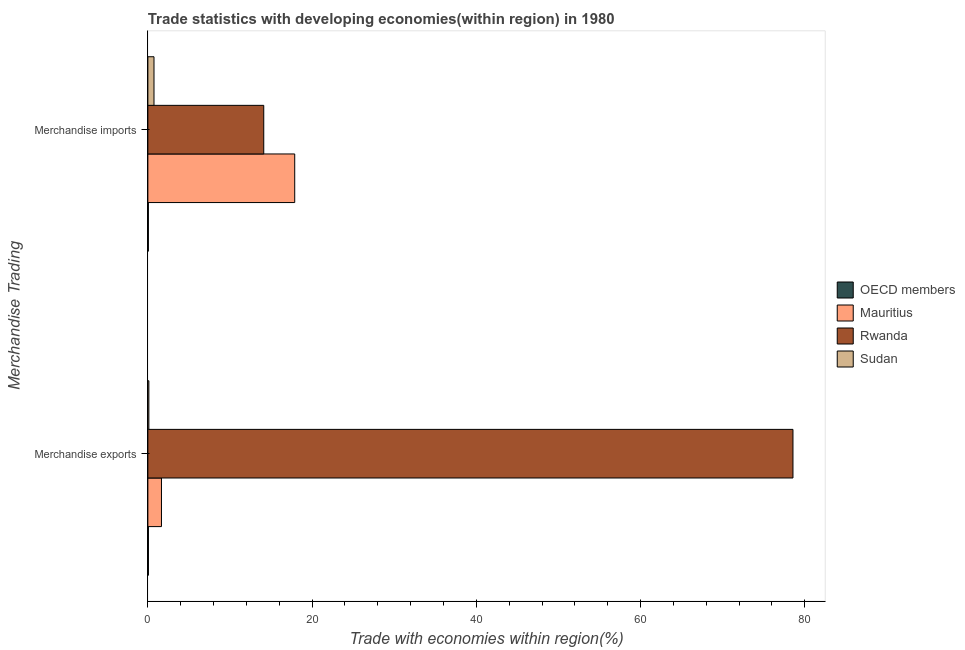How many different coloured bars are there?
Keep it short and to the point. 4. How many bars are there on the 1st tick from the bottom?
Offer a very short reply. 4. What is the label of the 2nd group of bars from the top?
Your answer should be compact. Merchandise exports. What is the merchandise exports in OECD members?
Your answer should be compact. 0.07. Across all countries, what is the maximum merchandise exports?
Keep it short and to the point. 78.56. Across all countries, what is the minimum merchandise imports?
Offer a very short reply. 0.06. In which country was the merchandise exports maximum?
Offer a very short reply. Rwanda. In which country was the merchandise imports minimum?
Your response must be concise. OECD members. What is the total merchandise imports in the graph?
Make the answer very short. 32.8. What is the difference between the merchandise exports in OECD members and that in Mauritius?
Your response must be concise. -1.59. What is the difference between the merchandise exports in Sudan and the merchandise imports in OECD members?
Provide a short and direct response. 0.06. What is the average merchandise exports per country?
Provide a short and direct response. 20.1. What is the difference between the merchandise imports and merchandise exports in Mauritius?
Your answer should be compact. 16.23. What is the ratio of the merchandise exports in Mauritius to that in Rwanda?
Offer a very short reply. 0.02. Are all the bars in the graph horizontal?
Make the answer very short. Yes. What is the difference between two consecutive major ticks on the X-axis?
Provide a short and direct response. 20. Are the values on the major ticks of X-axis written in scientific E-notation?
Ensure brevity in your answer.  No. Does the graph contain any zero values?
Offer a very short reply. No. Where does the legend appear in the graph?
Your answer should be very brief. Center right. How many legend labels are there?
Offer a very short reply. 4. How are the legend labels stacked?
Offer a very short reply. Vertical. What is the title of the graph?
Keep it short and to the point. Trade statistics with developing economies(within region) in 1980. What is the label or title of the X-axis?
Offer a terse response. Trade with economies within region(%). What is the label or title of the Y-axis?
Make the answer very short. Merchandise Trading. What is the Trade with economies within region(%) in OECD members in Merchandise exports?
Offer a very short reply. 0.07. What is the Trade with economies within region(%) in Mauritius in Merchandise exports?
Keep it short and to the point. 1.66. What is the Trade with economies within region(%) of Rwanda in Merchandise exports?
Give a very brief answer. 78.56. What is the Trade with economies within region(%) in Sudan in Merchandise exports?
Your response must be concise. 0.12. What is the Trade with economies within region(%) of OECD members in Merchandise imports?
Provide a short and direct response. 0.06. What is the Trade with economies within region(%) of Mauritius in Merchandise imports?
Your response must be concise. 17.88. What is the Trade with economies within region(%) in Rwanda in Merchandise imports?
Make the answer very short. 14.11. What is the Trade with economies within region(%) of Sudan in Merchandise imports?
Your response must be concise. 0.75. Across all Merchandise Trading, what is the maximum Trade with economies within region(%) of OECD members?
Your response must be concise. 0.07. Across all Merchandise Trading, what is the maximum Trade with economies within region(%) in Mauritius?
Provide a short and direct response. 17.88. Across all Merchandise Trading, what is the maximum Trade with economies within region(%) in Rwanda?
Provide a succinct answer. 78.56. Across all Merchandise Trading, what is the maximum Trade with economies within region(%) of Sudan?
Keep it short and to the point. 0.75. Across all Merchandise Trading, what is the minimum Trade with economies within region(%) in OECD members?
Keep it short and to the point. 0.06. Across all Merchandise Trading, what is the minimum Trade with economies within region(%) in Mauritius?
Your response must be concise. 1.66. Across all Merchandise Trading, what is the minimum Trade with economies within region(%) of Rwanda?
Offer a terse response. 14.11. Across all Merchandise Trading, what is the minimum Trade with economies within region(%) of Sudan?
Provide a succinct answer. 0.12. What is the total Trade with economies within region(%) of OECD members in the graph?
Offer a very short reply. 0.13. What is the total Trade with economies within region(%) in Mauritius in the graph?
Provide a succinct answer. 19.54. What is the total Trade with economies within region(%) in Rwanda in the graph?
Provide a succinct answer. 92.67. What is the total Trade with economies within region(%) in Sudan in the graph?
Your answer should be compact. 0.87. What is the difference between the Trade with economies within region(%) of OECD members in Merchandise exports and that in Merchandise imports?
Give a very brief answer. 0.01. What is the difference between the Trade with economies within region(%) in Mauritius in Merchandise exports and that in Merchandise imports?
Provide a short and direct response. -16.23. What is the difference between the Trade with economies within region(%) of Rwanda in Merchandise exports and that in Merchandise imports?
Your response must be concise. 64.45. What is the difference between the Trade with economies within region(%) of Sudan in Merchandise exports and that in Merchandise imports?
Offer a terse response. -0.62. What is the difference between the Trade with economies within region(%) of OECD members in Merchandise exports and the Trade with economies within region(%) of Mauritius in Merchandise imports?
Give a very brief answer. -17.82. What is the difference between the Trade with economies within region(%) in OECD members in Merchandise exports and the Trade with economies within region(%) in Rwanda in Merchandise imports?
Give a very brief answer. -14.04. What is the difference between the Trade with economies within region(%) in OECD members in Merchandise exports and the Trade with economies within region(%) in Sudan in Merchandise imports?
Offer a terse response. -0.68. What is the difference between the Trade with economies within region(%) in Mauritius in Merchandise exports and the Trade with economies within region(%) in Rwanda in Merchandise imports?
Offer a very short reply. -12.46. What is the difference between the Trade with economies within region(%) of Mauritius in Merchandise exports and the Trade with economies within region(%) of Sudan in Merchandise imports?
Provide a succinct answer. 0.91. What is the difference between the Trade with economies within region(%) in Rwanda in Merchandise exports and the Trade with economies within region(%) in Sudan in Merchandise imports?
Your answer should be compact. 77.81. What is the average Trade with economies within region(%) in OECD members per Merchandise Trading?
Provide a short and direct response. 0.06. What is the average Trade with economies within region(%) of Mauritius per Merchandise Trading?
Make the answer very short. 9.77. What is the average Trade with economies within region(%) of Rwanda per Merchandise Trading?
Ensure brevity in your answer.  46.33. What is the average Trade with economies within region(%) in Sudan per Merchandise Trading?
Ensure brevity in your answer.  0.43. What is the difference between the Trade with economies within region(%) of OECD members and Trade with economies within region(%) of Mauritius in Merchandise exports?
Provide a succinct answer. -1.59. What is the difference between the Trade with economies within region(%) of OECD members and Trade with economies within region(%) of Rwanda in Merchandise exports?
Offer a very short reply. -78.49. What is the difference between the Trade with economies within region(%) of OECD members and Trade with economies within region(%) of Sudan in Merchandise exports?
Give a very brief answer. -0.05. What is the difference between the Trade with economies within region(%) of Mauritius and Trade with economies within region(%) of Rwanda in Merchandise exports?
Your answer should be very brief. -76.9. What is the difference between the Trade with economies within region(%) of Mauritius and Trade with economies within region(%) of Sudan in Merchandise exports?
Make the answer very short. 1.53. What is the difference between the Trade with economies within region(%) in Rwanda and Trade with economies within region(%) in Sudan in Merchandise exports?
Keep it short and to the point. 78.44. What is the difference between the Trade with economies within region(%) of OECD members and Trade with economies within region(%) of Mauritius in Merchandise imports?
Provide a short and direct response. -17.82. What is the difference between the Trade with economies within region(%) of OECD members and Trade with economies within region(%) of Rwanda in Merchandise imports?
Provide a succinct answer. -14.05. What is the difference between the Trade with economies within region(%) in OECD members and Trade with economies within region(%) in Sudan in Merchandise imports?
Your response must be concise. -0.69. What is the difference between the Trade with economies within region(%) of Mauritius and Trade with economies within region(%) of Rwanda in Merchandise imports?
Provide a short and direct response. 3.77. What is the difference between the Trade with economies within region(%) of Mauritius and Trade with economies within region(%) of Sudan in Merchandise imports?
Make the answer very short. 17.14. What is the difference between the Trade with economies within region(%) in Rwanda and Trade with economies within region(%) in Sudan in Merchandise imports?
Offer a very short reply. 13.37. What is the ratio of the Trade with economies within region(%) of OECD members in Merchandise exports to that in Merchandise imports?
Your answer should be very brief. 1.11. What is the ratio of the Trade with economies within region(%) of Mauritius in Merchandise exports to that in Merchandise imports?
Keep it short and to the point. 0.09. What is the ratio of the Trade with economies within region(%) of Rwanda in Merchandise exports to that in Merchandise imports?
Provide a succinct answer. 5.57. What is the ratio of the Trade with economies within region(%) of Sudan in Merchandise exports to that in Merchandise imports?
Your response must be concise. 0.16. What is the difference between the highest and the second highest Trade with economies within region(%) of OECD members?
Make the answer very short. 0.01. What is the difference between the highest and the second highest Trade with economies within region(%) of Mauritius?
Your answer should be very brief. 16.23. What is the difference between the highest and the second highest Trade with economies within region(%) in Rwanda?
Ensure brevity in your answer.  64.45. What is the difference between the highest and the second highest Trade with economies within region(%) in Sudan?
Offer a terse response. 0.62. What is the difference between the highest and the lowest Trade with economies within region(%) of OECD members?
Make the answer very short. 0.01. What is the difference between the highest and the lowest Trade with economies within region(%) of Mauritius?
Your answer should be very brief. 16.23. What is the difference between the highest and the lowest Trade with economies within region(%) of Rwanda?
Your answer should be compact. 64.45. What is the difference between the highest and the lowest Trade with economies within region(%) in Sudan?
Offer a terse response. 0.62. 